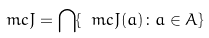Convert formula to latex. <formula><loc_0><loc_0><loc_500><loc_500>\ m c { J } = { \bigcap } \{ \ m c { J } ( a ) \colon a \in A \}</formula> 